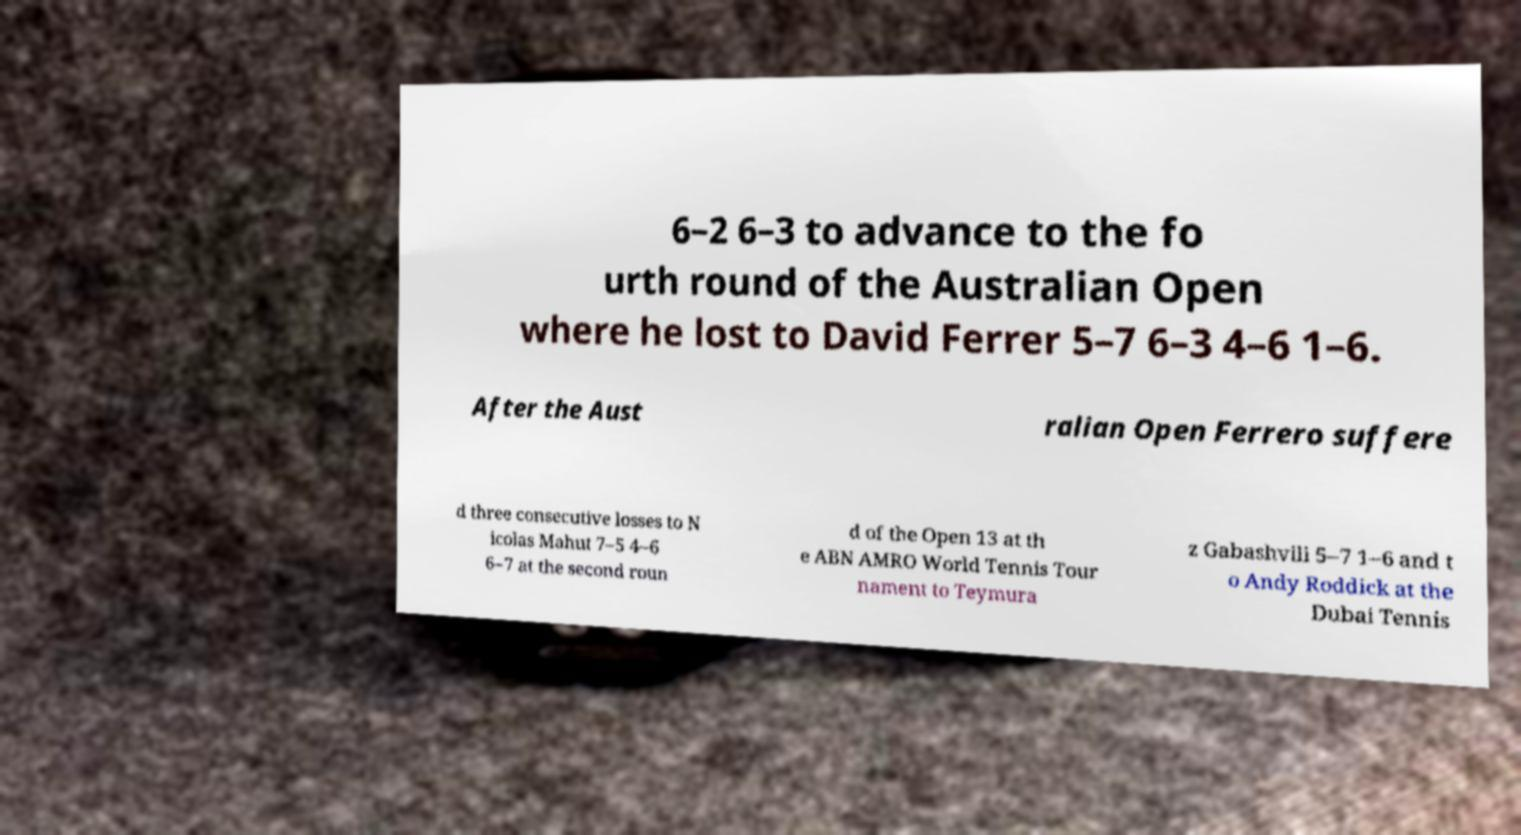There's text embedded in this image that I need extracted. Can you transcribe it verbatim? 6–2 6–3 to advance to the fo urth round of the Australian Open where he lost to David Ferrer 5–7 6–3 4–6 1–6. After the Aust ralian Open Ferrero suffere d three consecutive losses to N icolas Mahut 7–5 4–6 6–7 at the second roun d of the Open 13 at th e ABN AMRO World Tennis Tour nament to Teymura z Gabashvili 5–7 1–6 and t o Andy Roddick at the Dubai Tennis 